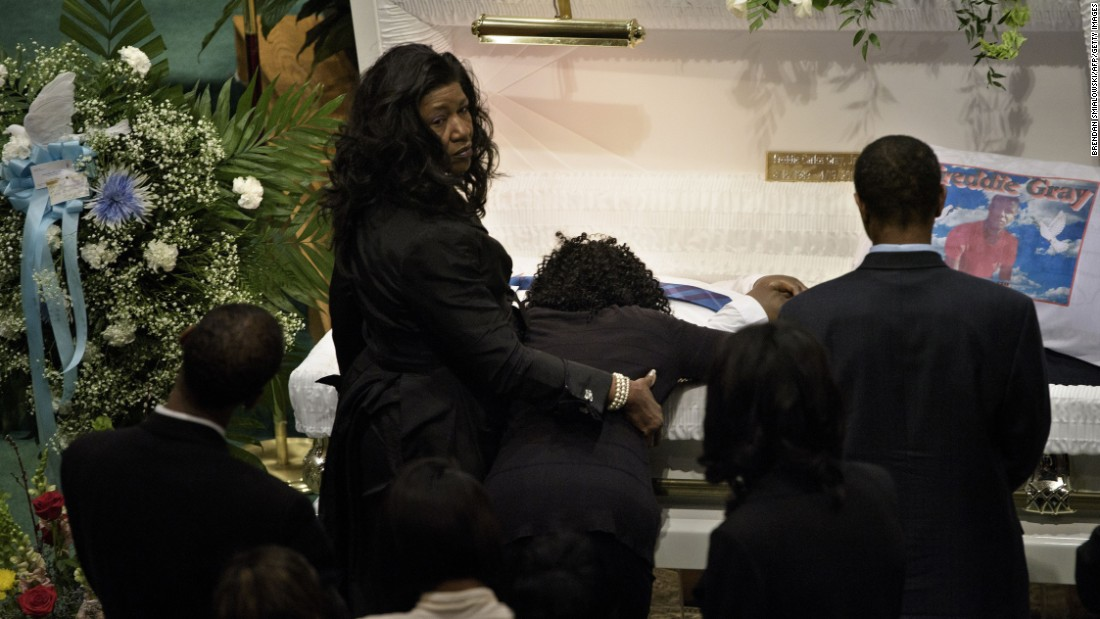How does the body language of the individuals around the casket reflect their emotional state? The body language of the individuals around the casket powerfully manifests their profound sorrow. The person bending over the casket, with their head bowed low, likely reflects a deep personal loss, suggesting a close relationship with the deceased, possibly saying a final, private goodbye. Accompanying, a woman stands supportively, her hand on the mourner's back–a gesture of solace. Her expression, a complex tapestry of grief and resilience, speaks volumes about her role as a pillar of strength amidst this mourning. Other attendees, also with heads bowed, participate in this collective ritual of grief, each absorbed in their reflections or silent prayers, further emphasizing the solemn atmosphere of the ceremony. This setting suggests a communal sharing of loss, unified yet personal in each individual's expression of grief. 